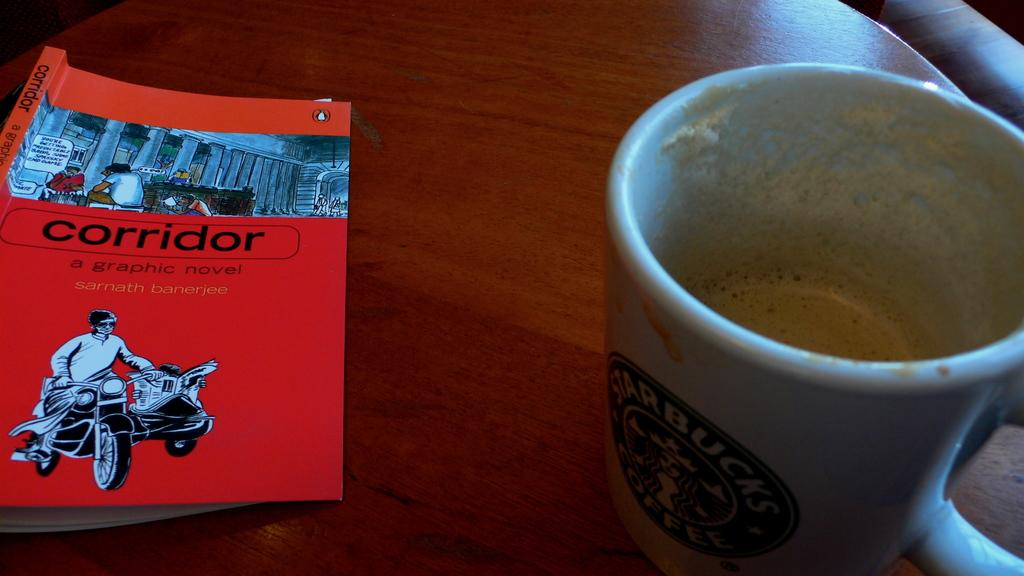Provide a one-sentence caption for the provided image. A mostly empty starbucks mug with a red book next to it. 